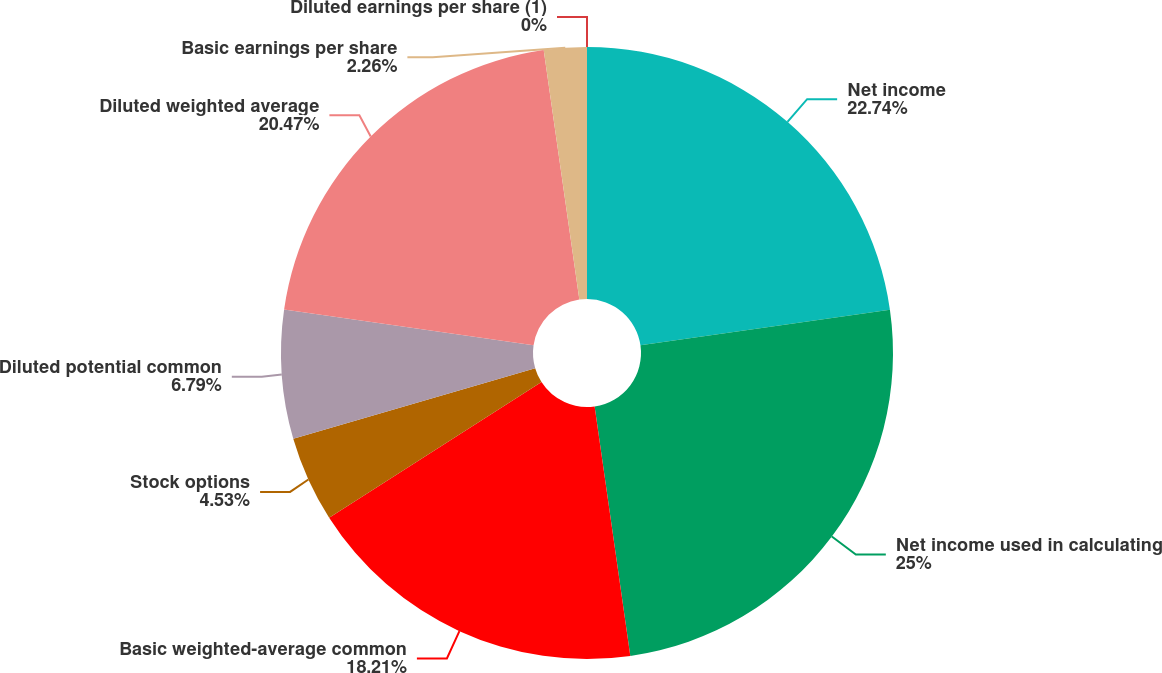<chart> <loc_0><loc_0><loc_500><loc_500><pie_chart><fcel>Net income<fcel>Net income used in calculating<fcel>Basic weighted-average common<fcel>Stock options<fcel>Diluted potential common<fcel>Diluted weighted average<fcel>Basic earnings per share<fcel>Diluted earnings per share (1)<nl><fcel>22.74%<fcel>25.0%<fcel>18.21%<fcel>4.53%<fcel>6.79%<fcel>20.47%<fcel>2.26%<fcel>0.0%<nl></chart> 